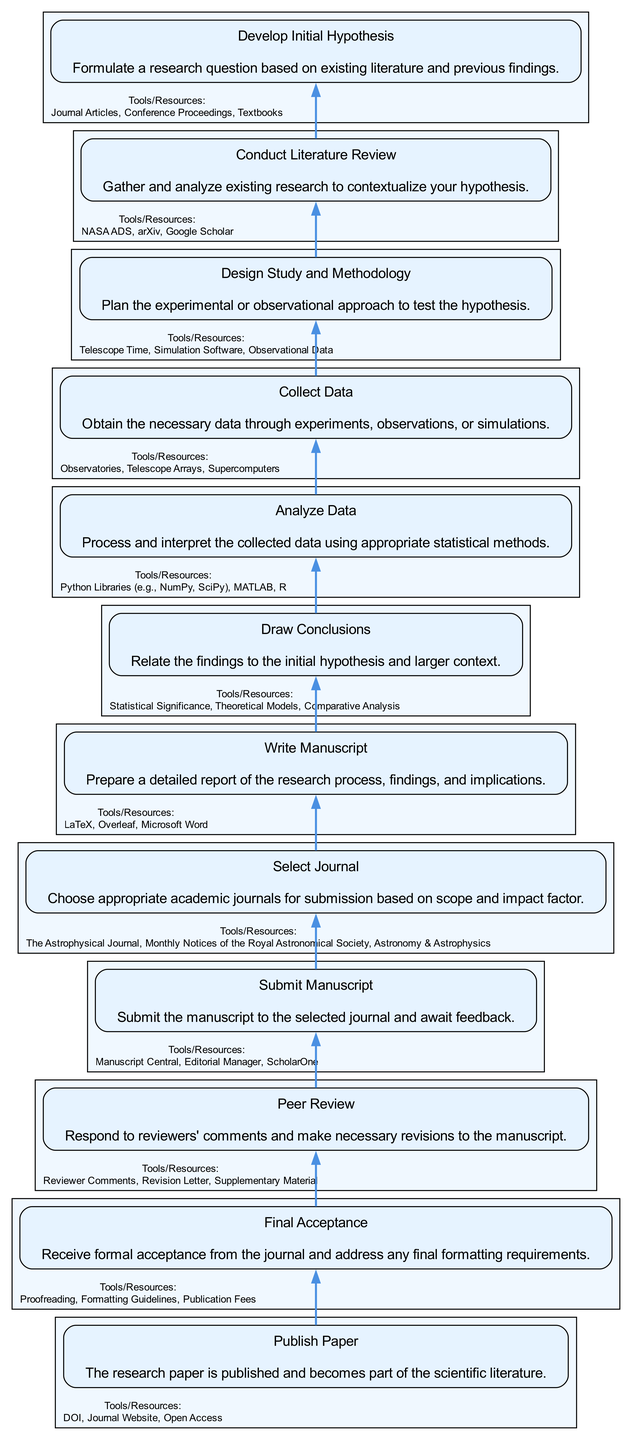What is the first step in the publication process? The first step, as shown at the bottom of the diagram, is "Develop Initial Hypothesis."
Answer: Develop Initial Hypothesis How many entities are listed under "Collect Data"? By counting the number of entities shown in the "Collect Data" section of the diagram, there are three entities: "Observatories," "Telescope Arrays," and "Supercomputers."
Answer: 3 Which step directly precedes "Write Manuscript"? By moving upwards in the flow chart, we find that "Draw Conclusions" is the step directly preceding "Write Manuscript."
Answer: Draw Conclusions What is the main focus of the "Peer Review" step? In the peer review step, the focus is on responding to reviewers' comments and making necessary revisions, as indicated in the description of this step.
Answer: Responding to reviewers' comments How many steps are included in the entire process from initial hypothesis to publication? The diagram lists a total of twelve steps when counted from bottom to top, beginning with "Develop Initial Hypothesis" and ending with "Publish Paper."
Answer: 12 What resources are mentioned in the "Design Study and Methodology" step? The entities listed under the "Design Study and Methodology" step are "Telescope Time," "Simulation Software," and "Observational Data," which provide the necessary tools for study design.
Answer: Telescope Time, Simulation Software, Observational Data Which step is immediately followed by "Final Acceptance"? "Peer Review" is the step that immediately precedes "Final Acceptance," indicating the process that comes before acceptance by the journal.
Answer: Peer Review What is the final step in the research paper publication process? The last and final step in the flow chart of the publication process is "Publish Paper." This step signifies that the research paper has been officially published.
Answer: Publish Paper What action is taken during the "Submit Manuscript" step? During the "Submit Manuscript" step, the action taken is the submission of the manuscript to the selected journal while awaiting feedback, highlighting the transition to the review phase.
Answer: Submit the manuscript to the selected journal Which tools are suggested for writing the manuscript? The tools suggested for the writing process include "LaTeX," "Overleaf," and "Microsoft Word," which are commonly used software for scientific writing.
Answer: LaTeX, Overleaf, Microsoft Word 